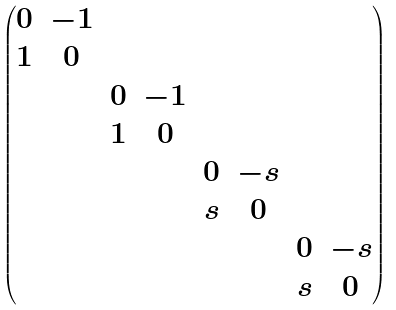Convert formula to latex. <formula><loc_0><loc_0><loc_500><loc_500>\begin{pmatrix} 0 & - 1 & & & & & & \\ 1 & 0 & & & & & & \\ & & 0 & - 1 & & & & \\ & & 1 & 0 & & & & \\ & & & & 0 & - s & & \\ & & & & s & 0 & & \\ & & & & & & 0 & - s \\ & & & & & & s & 0 \end{pmatrix}</formula> 